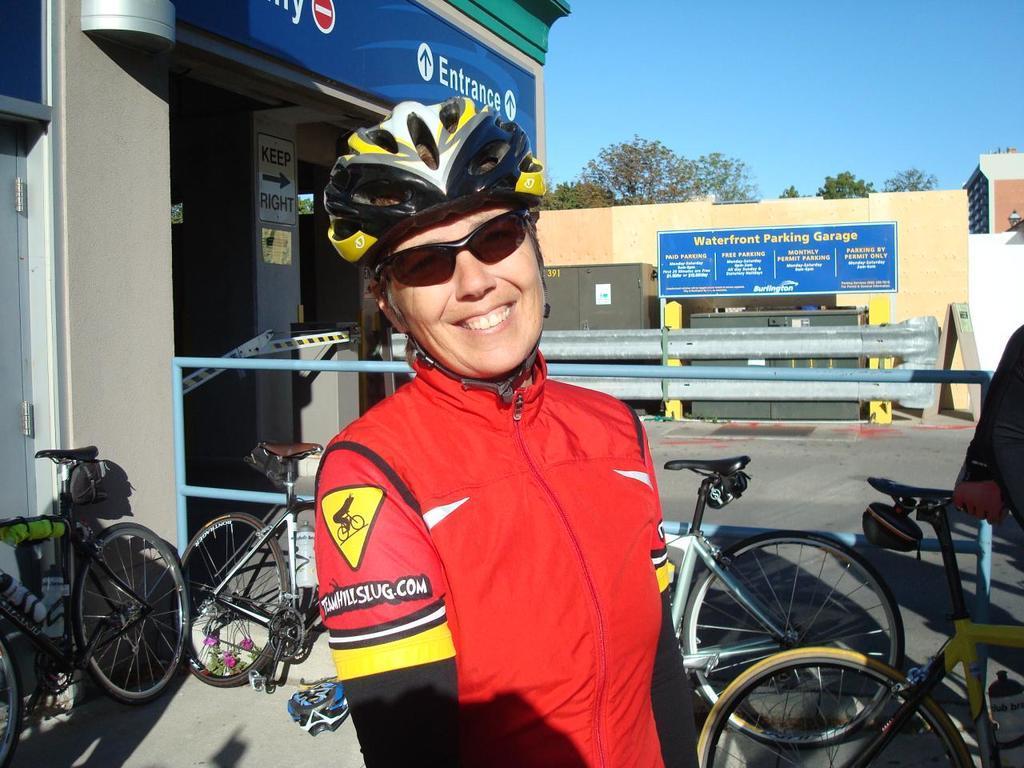How would you summarize this image in a sentence or two? In this picture we can observe a person wearing a red color jacket, spectacles and a helmet on their head. The person is smiling. We can observe some bicycles parked here. We can observe a building on the left side. There is a blue color board fixed to the yellow color poles here. In the background there is a sky and there are some trees. 